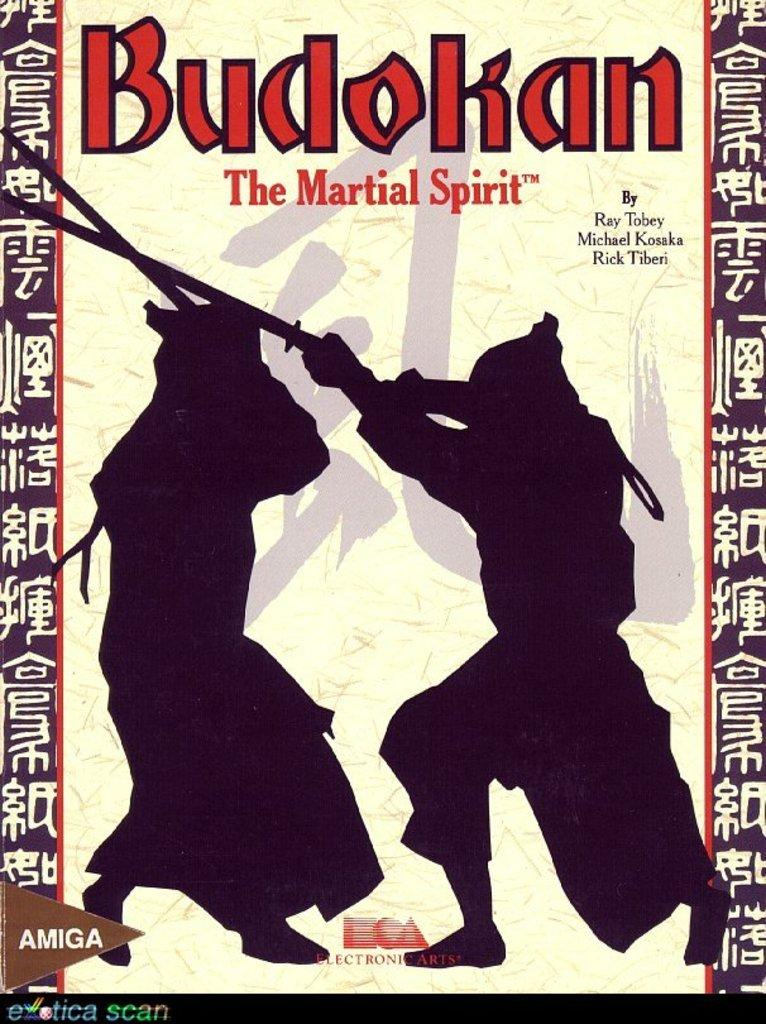What is featured on the poster in the image? The poster in the image contains both text and pictures. Can you describe the content of the poster? The poster contains text and pictures, but the specific content cannot be determined from the provided facts. How many snakes are slithering across the poster in the image? There are no snakes present on the poster in the image. What type of answer is provided at the bottom of the poster? The provided facts do not mention any answers on the poster, so we cannot determine if there is an answer or what type it might be. 